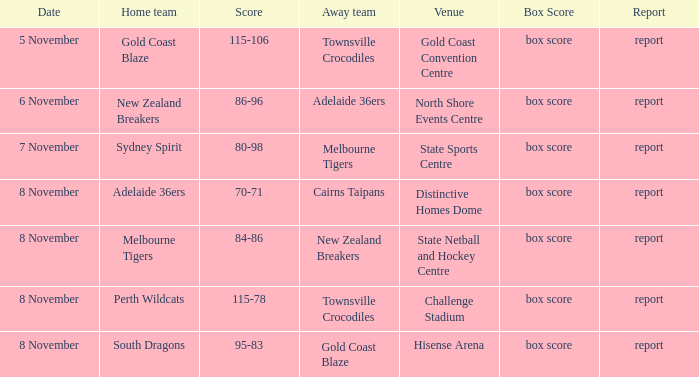Could you parse the entire table? {'header': ['Date', 'Home team', 'Score', 'Away team', 'Venue', 'Box Score', 'Report'], 'rows': [['5 November', 'Gold Coast Blaze', '115-106', 'Townsville Crocodiles', 'Gold Coast Convention Centre', 'box score', 'report'], ['6 November', 'New Zealand Breakers', '86-96', 'Adelaide 36ers', 'North Shore Events Centre', 'box score', 'report'], ['7 November', 'Sydney Spirit', '80-98', 'Melbourne Tigers', 'State Sports Centre', 'box score', 'report'], ['8 November', 'Adelaide 36ers', '70-71', 'Cairns Taipans', 'Distinctive Homes Dome', 'box score', 'report'], ['8 November', 'Melbourne Tigers', '84-86', 'New Zealand Breakers', 'State Netball and Hockey Centre', 'box score', 'report'], ['8 November', 'Perth Wildcats', '115-78', 'Townsville Crocodiles', 'Challenge Stadium', 'box score', 'report'], ['8 November', 'South Dragons', '95-83', 'Gold Coast Blaze', 'Hisense Arena', 'box score', 'report']]} What was the announcement at state sports centre? Report. 